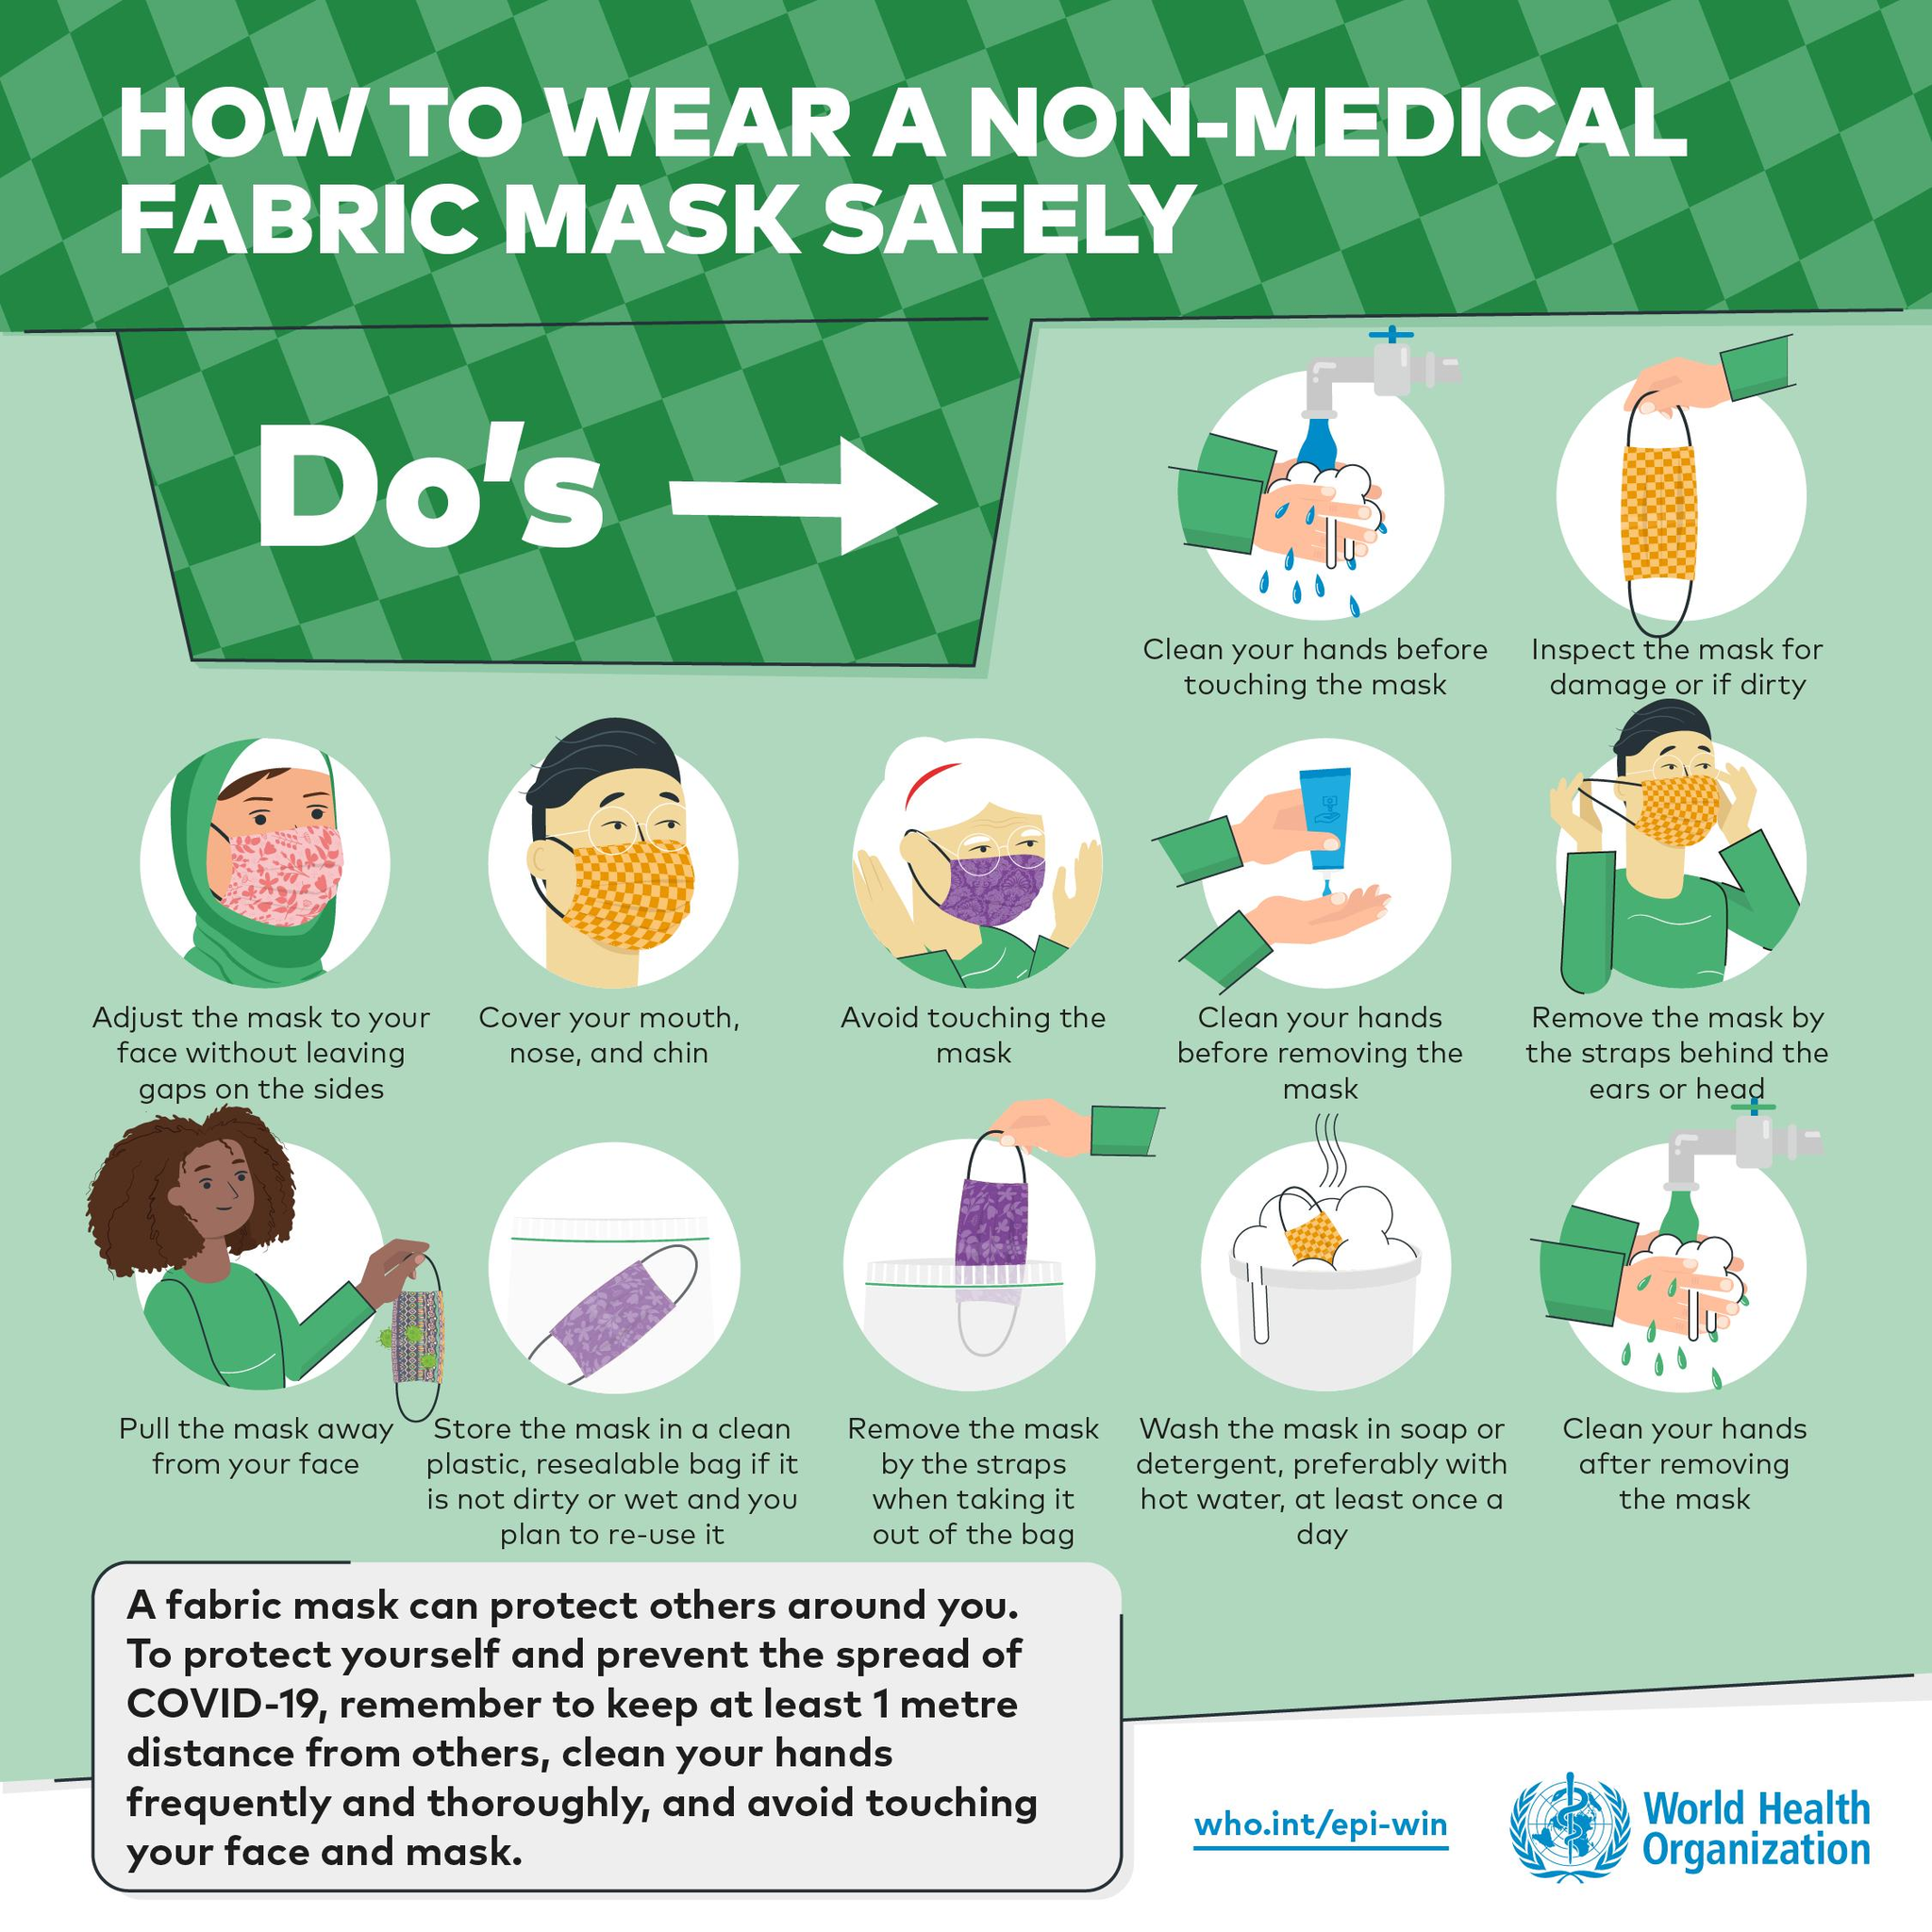Indicate a few pertinent items in this graphic. I observed that only one pink-colored mask was shown in the video. The infographic shows 5 people. The color of the mask worn by the old lady is purple. Out of the masks that are shown, four of them are yellow in color. The infographic displays 12 dos. 